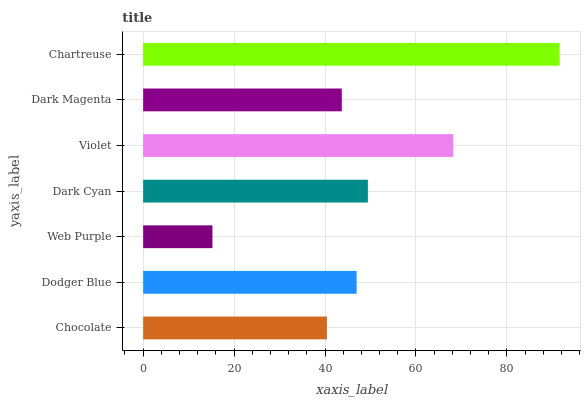Is Web Purple the minimum?
Answer yes or no. Yes. Is Chartreuse the maximum?
Answer yes or no. Yes. Is Dodger Blue the minimum?
Answer yes or no. No. Is Dodger Blue the maximum?
Answer yes or no. No. Is Dodger Blue greater than Chocolate?
Answer yes or no. Yes. Is Chocolate less than Dodger Blue?
Answer yes or no. Yes. Is Chocolate greater than Dodger Blue?
Answer yes or no. No. Is Dodger Blue less than Chocolate?
Answer yes or no. No. Is Dodger Blue the high median?
Answer yes or no. Yes. Is Dodger Blue the low median?
Answer yes or no. Yes. Is Chocolate the high median?
Answer yes or no. No. Is Chocolate the low median?
Answer yes or no. No. 